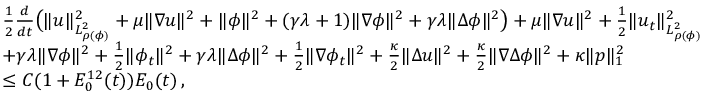<formula> <loc_0><loc_0><loc_500><loc_500>\begin{array} { r l } & { \frac { 1 } { 2 } \frac { d } { d t } \left ( \| u \| _ { L _ { \rho ( \phi ) } ^ { 2 } } ^ { 2 } + \mu \| \nabla u \| ^ { 2 } + \| \phi \| ^ { 2 } + ( \gamma \lambda + 1 ) \| \nabla \phi \| ^ { 2 } + \gamma \lambda \| \Delta \phi \| ^ { 2 } \right ) + \mu \| \nabla u \| ^ { 2 } + \frac { 1 } { 2 } \| u _ { t } \| _ { L _ { \rho ( \phi ) } ^ { 2 } } ^ { 2 } } \\ & { + \gamma \lambda \| \nabla \phi \| ^ { 2 } + \frac { 1 } { 2 } \| \phi _ { t } \| ^ { 2 } + \gamma \lambda \| \Delta \phi \| ^ { 2 } + \frac { 1 } { 2 } \| \nabla \phi _ { t } \| ^ { 2 } + \frac { \kappa } { 2 } \| \Delta u \| ^ { 2 } + \frac { \kappa } { 2 } \| \nabla \Delta \phi \| ^ { 2 } + \kappa \| p \| _ { 1 } ^ { 2 } } \\ & { \leq C ( 1 + E _ { 0 } ^ { 1 2 } ( t ) ) E _ { 0 } ( t ) \, , } \end{array}</formula> 